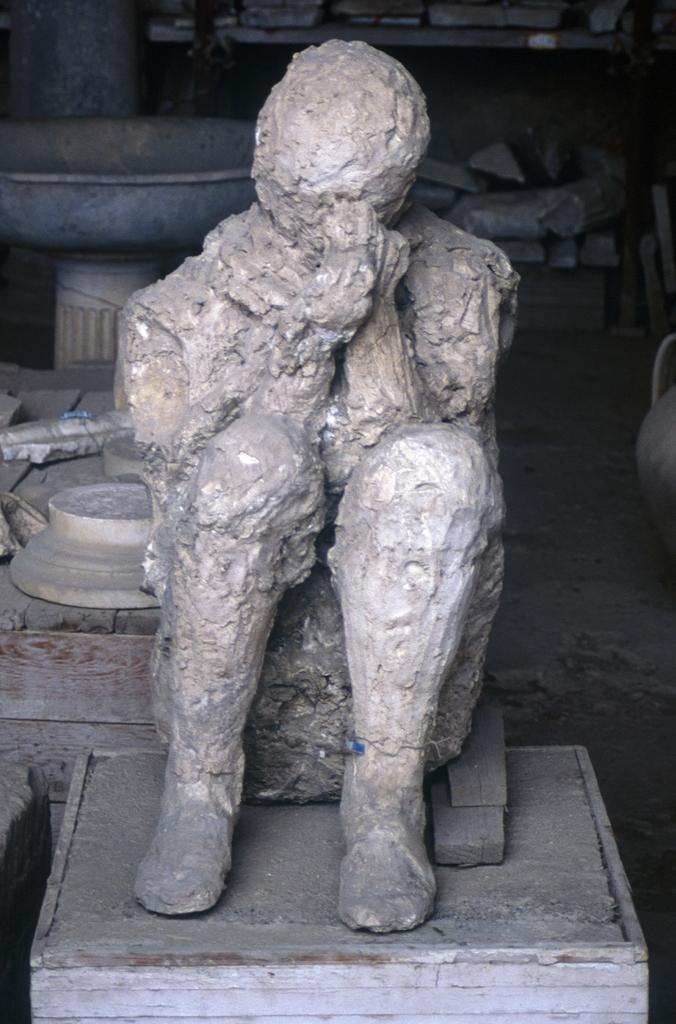Could you give a brief overview of what you see in this image? Here I can see a sculpture of a person is placed on a table. In the background, I can see some other objects. This is an inside view. 